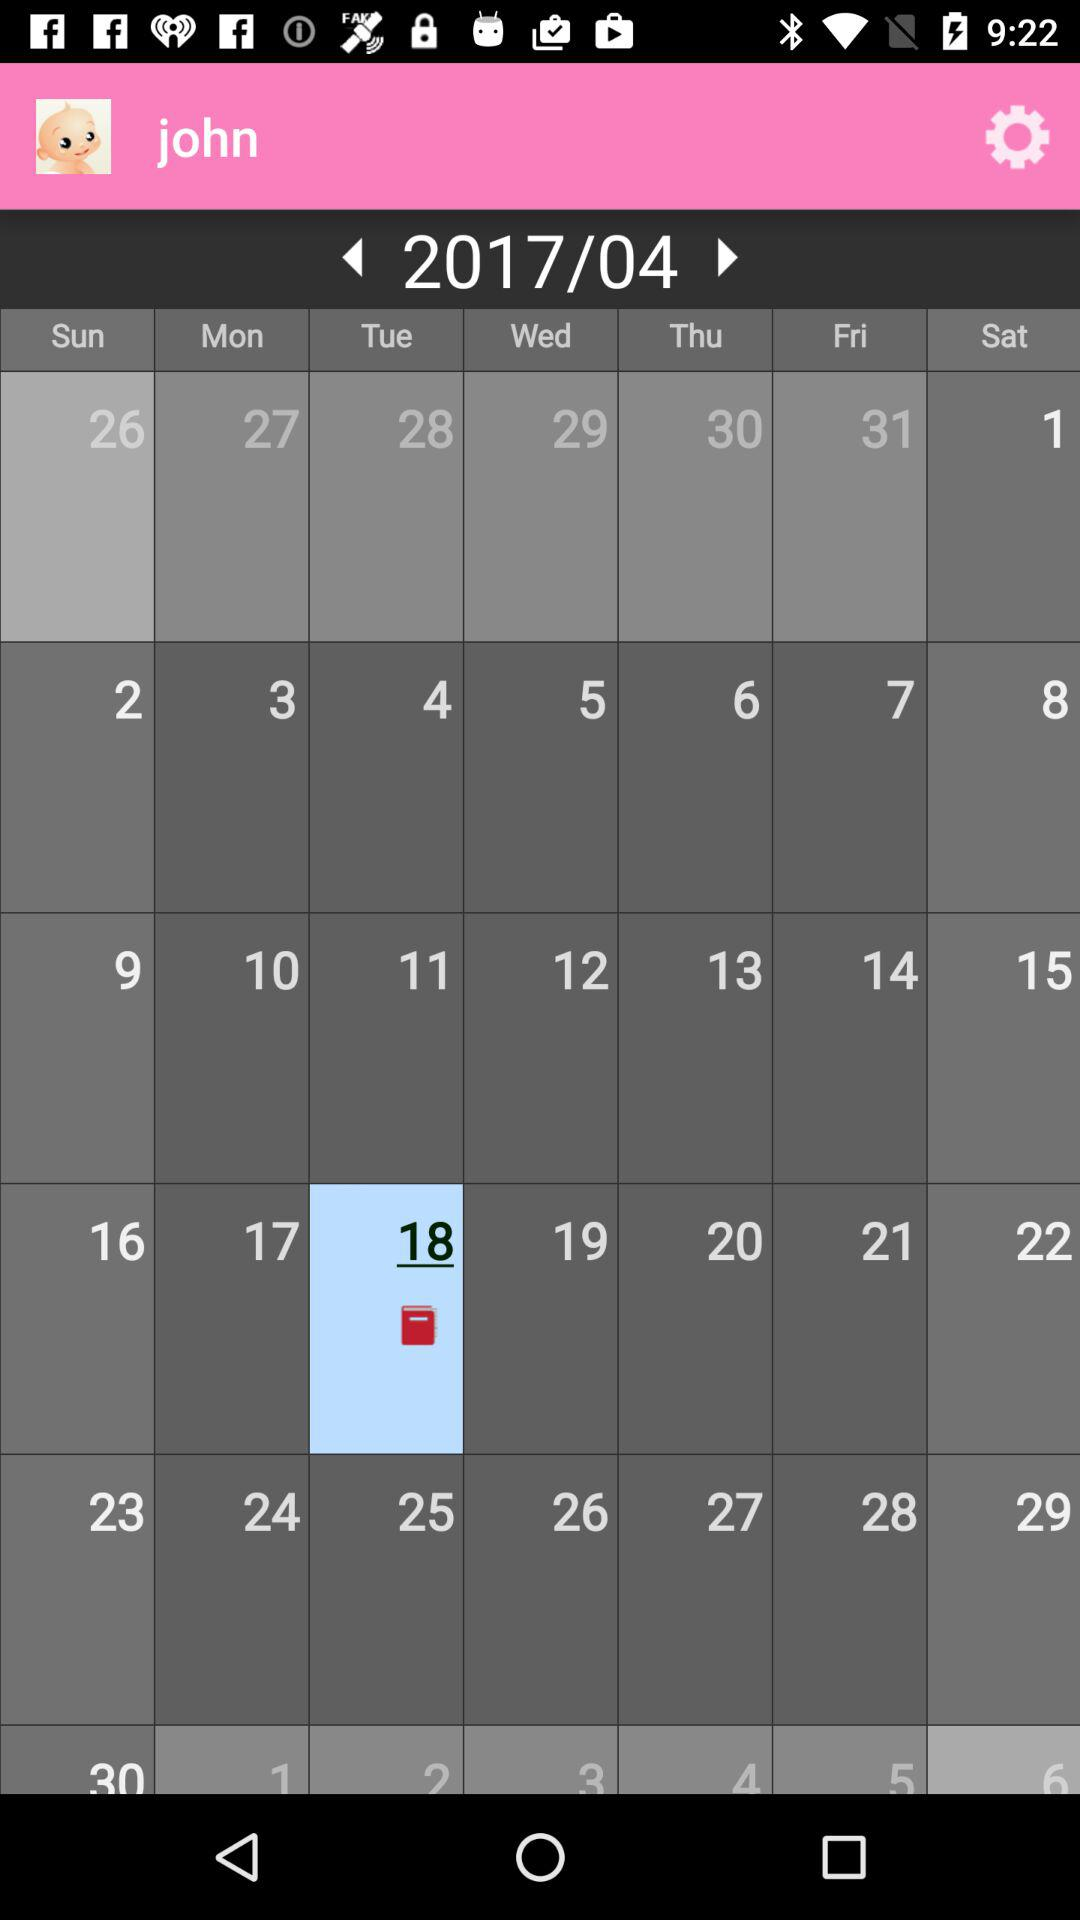What year does the calendar represent? The calendar represents the year 2017. 